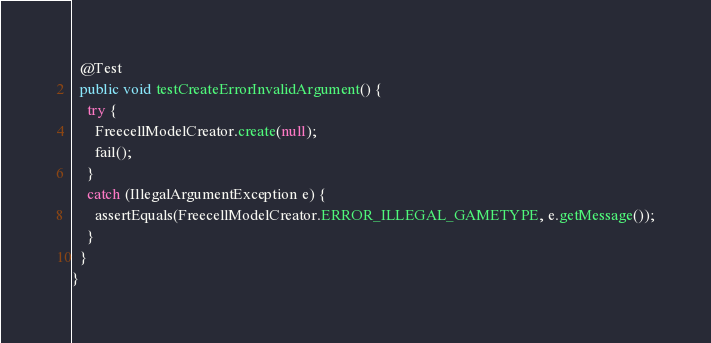Convert code to text. <code><loc_0><loc_0><loc_500><loc_500><_Java_>  @Test
  public void testCreateErrorInvalidArgument() {
    try {
      FreecellModelCreator.create(null);
      fail();
    }
    catch (IllegalArgumentException e) {
      assertEquals(FreecellModelCreator.ERROR_ILLEGAL_GAMETYPE, e.getMessage());
    }
  }
}
</code> 